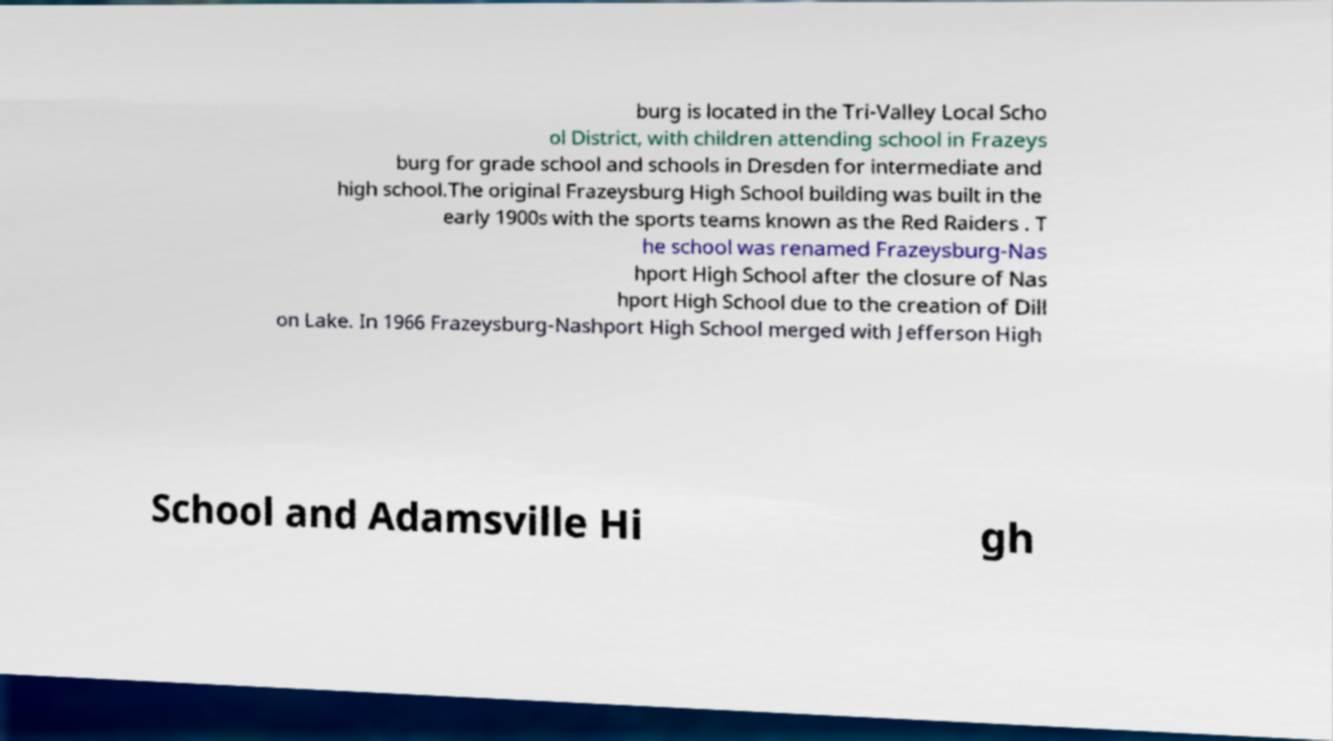Could you extract and type out the text from this image? burg is located in the Tri-Valley Local Scho ol District, with children attending school in Frazeys burg for grade school and schools in Dresden for intermediate and high school.The original Frazeysburg High School building was built in the early 1900s with the sports teams known as the Red Raiders . T he school was renamed Frazeysburg-Nas hport High School after the closure of Nas hport High School due to the creation of Dill on Lake. In 1966 Frazeysburg-Nashport High School merged with Jefferson High School and Adamsville Hi gh 